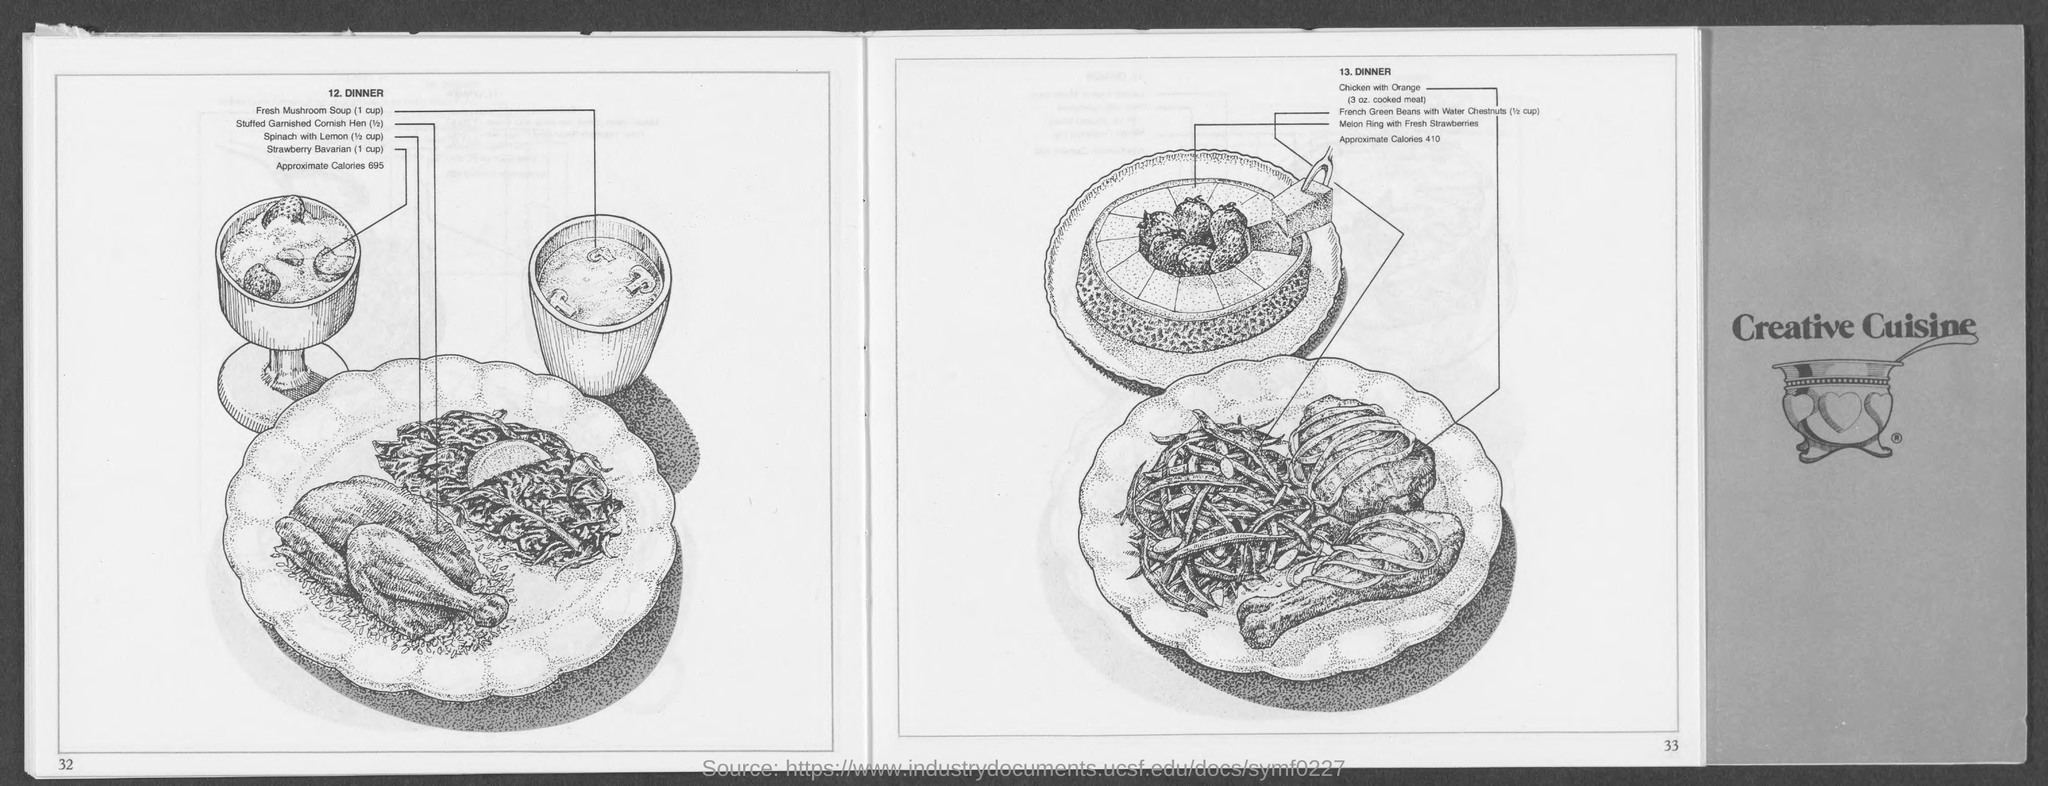What is the value of approximate calories of dinner under point number 12?
Ensure brevity in your answer.  695. What is the value of approximate calories of dinner under point number 13?
Offer a very short reply. 410. What is the name on the book cover?
Offer a terse response. Creative cuisine. Under number 13 what is the amount of chicken with orange?
Provide a short and direct response. 3. 